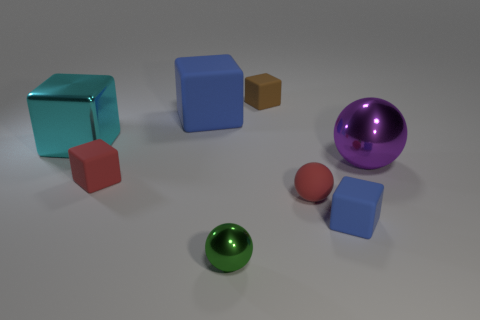Add 2 green spheres. How many objects exist? 10 Subtract all matte cubes. How many cubes are left? 1 Subtract all blocks. How many objects are left? 3 Subtract all gray metallic blocks. Subtract all large things. How many objects are left? 5 Add 8 large purple metallic objects. How many large purple metallic objects are left? 9 Add 4 tiny cyan metal balls. How many tiny cyan metal balls exist? 4 Subtract all purple balls. How many balls are left? 2 Subtract 0 blue balls. How many objects are left? 8 Subtract 2 cubes. How many cubes are left? 3 Subtract all red balls. Subtract all yellow cylinders. How many balls are left? 2 